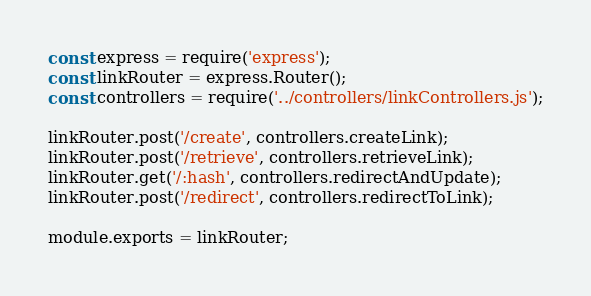<code> <loc_0><loc_0><loc_500><loc_500><_JavaScript_>const express = require('express');
const linkRouter = express.Router();
const controllers = require('../controllers/linkControllers.js');

linkRouter.post('/create', controllers.createLink);
linkRouter.post('/retrieve', controllers.retrieveLink);
linkRouter.get('/:hash', controllers.redirectAndUpdate);
linkRouter.post('/redirect', controllers.redirectToLink);

module.exports = linkRouter;
</code> 